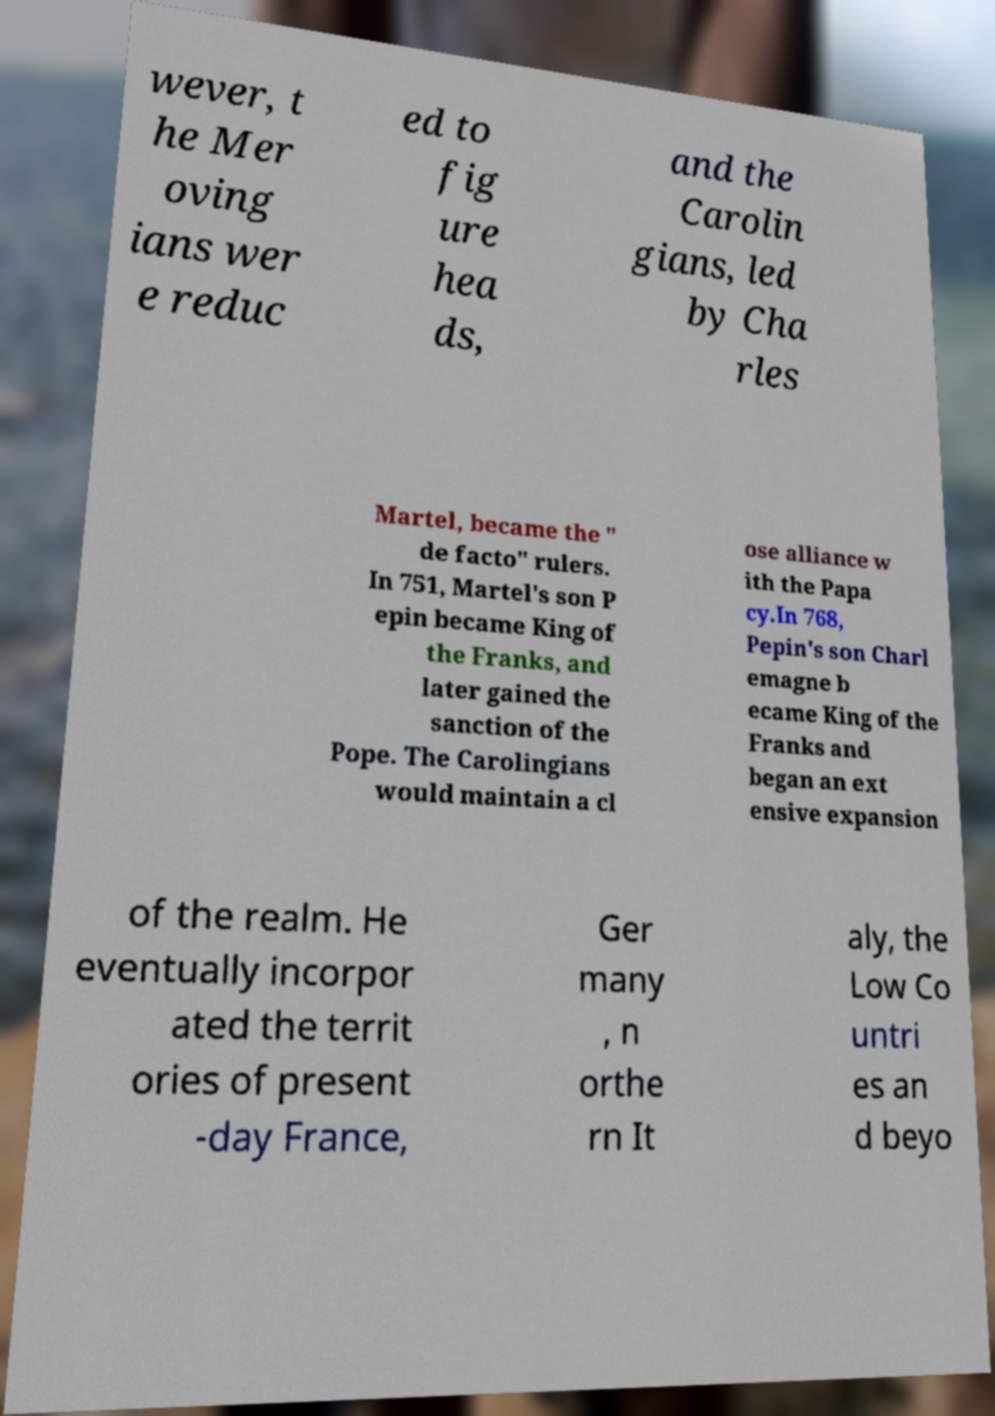I need the written content from this picture converted into text. Can you do that? wever, t he Mer oving ians wer e reduc ed to fig ure hea ds, and the Carolin gians, led by Cha rles Martel, became the " de facto" rulers. In 751, Martel's son P epin became King of the Franks, and later gained the sanction of the Pope. The Carolingians would maintain a cl ose alliance w ith the Papa cy.In 768, Pepin's son Charl emagne b ecame King of the Franks and began an ext ensive expansion of the realm. He eventually incorpor ated the territ ories of present -day France, Ger many , n orthe rn It aly, the Low Co untri es an d beyo 